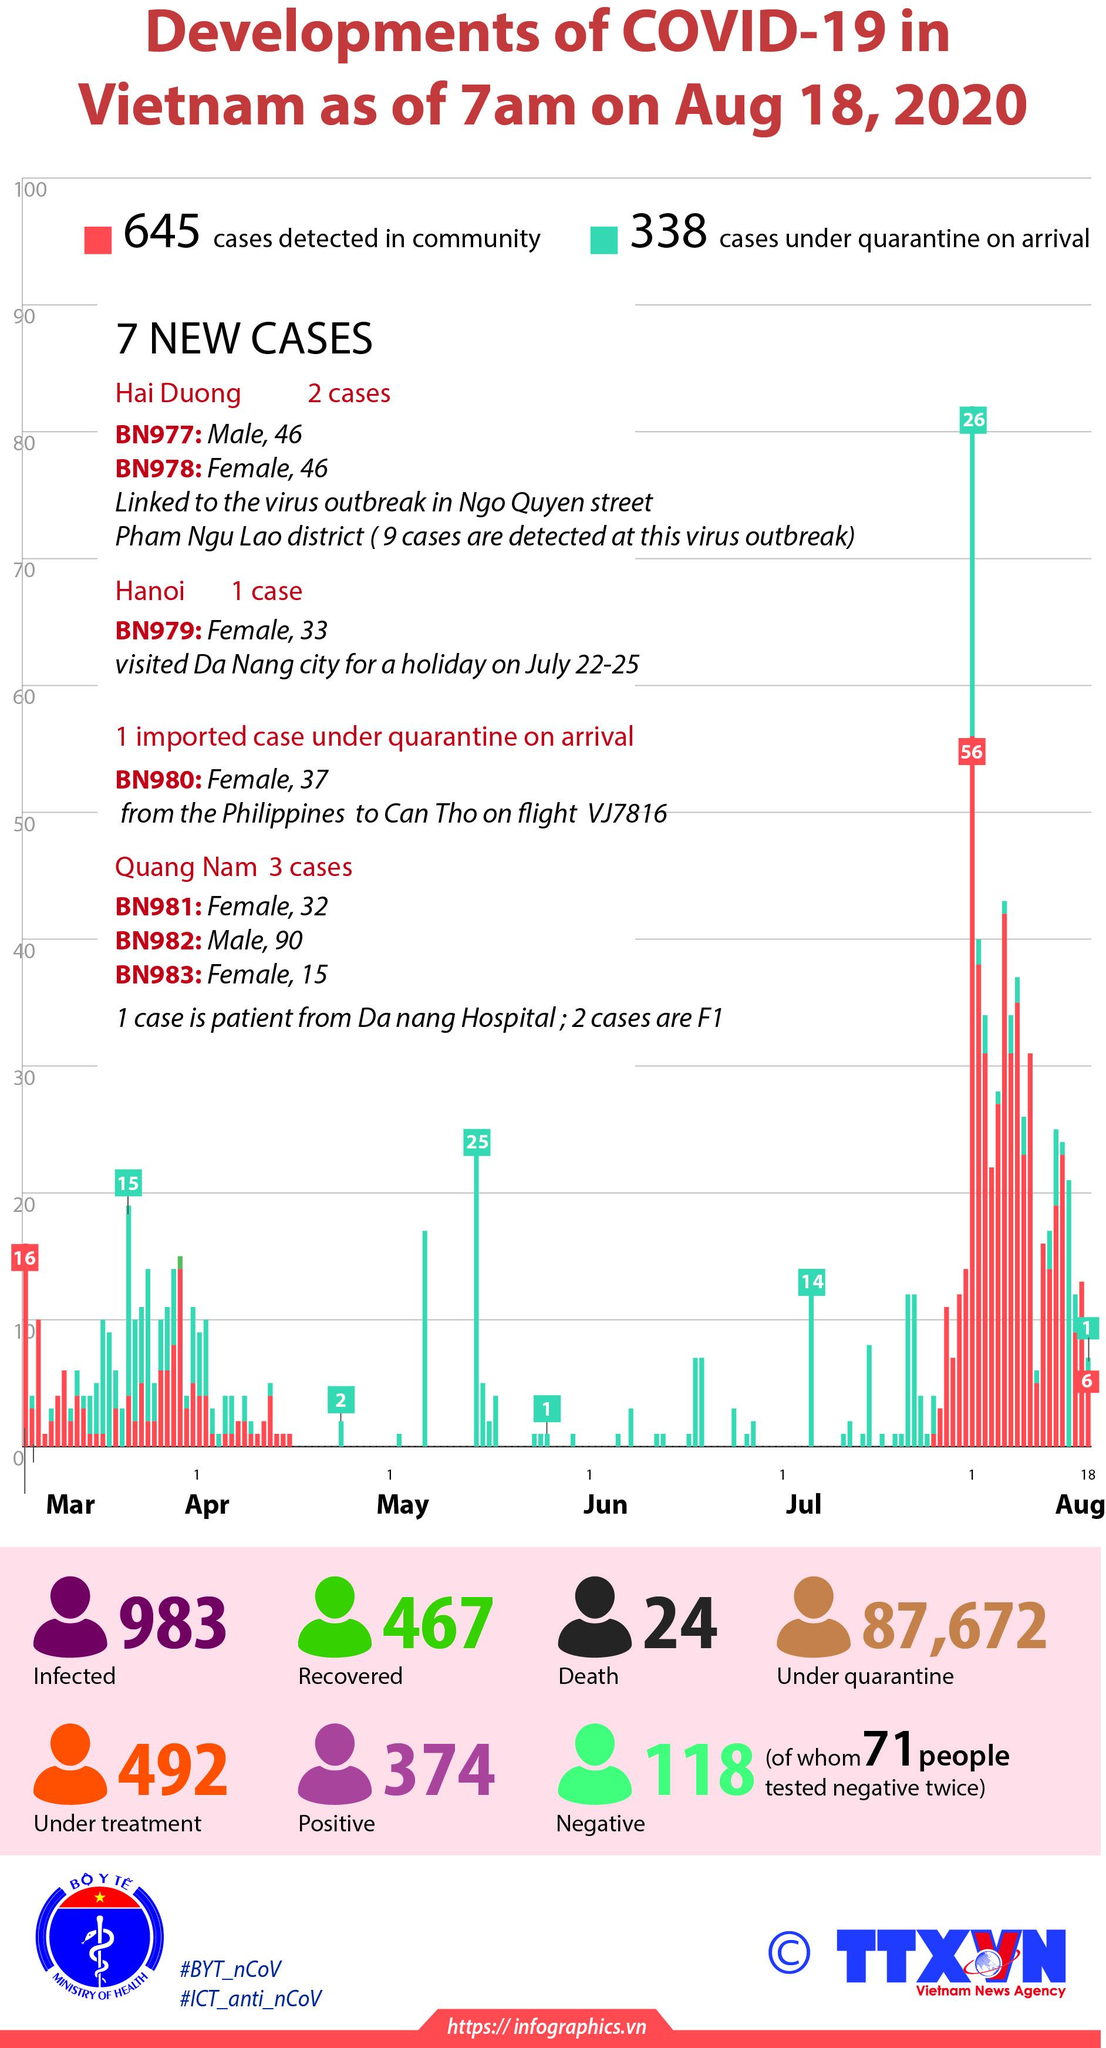Draw attention to some important aspects in this diagram. In Vietnam, as of February 16th, 983 individuals have contracted the COVID-19 virus, according to official government data. As of February 20, 2023, there are 87,672 individuals in Vietnam who are currently under quarantine due to the COVID-19 pandemic. As of August 18, 2020, the number of people who have tested positive for COVID-19 and are infected with the Corona virus is 374. As of June, a total of 26 cases were under quarantine upon arrival in the month of May. There are 492 individuals currently undergoing treatment. 